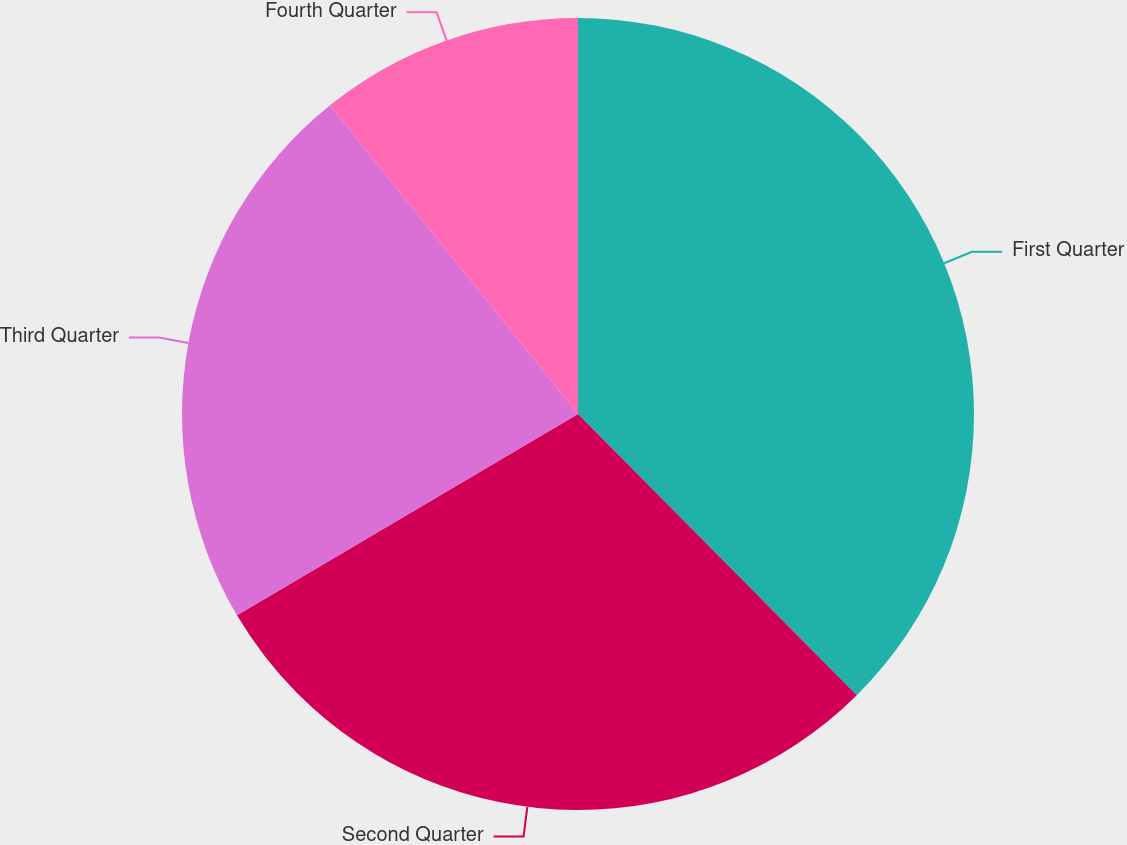<chart> <loc_0><loc_0><loc_500><loc_500><pie_chart><fcel>First Quarter<fcel>Second Quarter<fcel>Third Quarter<fcel>Fourth Quarter<nl><fcel>37.57%<fcel>28.94%<fcel>22.72%<fcel>10.77%<nl></chart> 